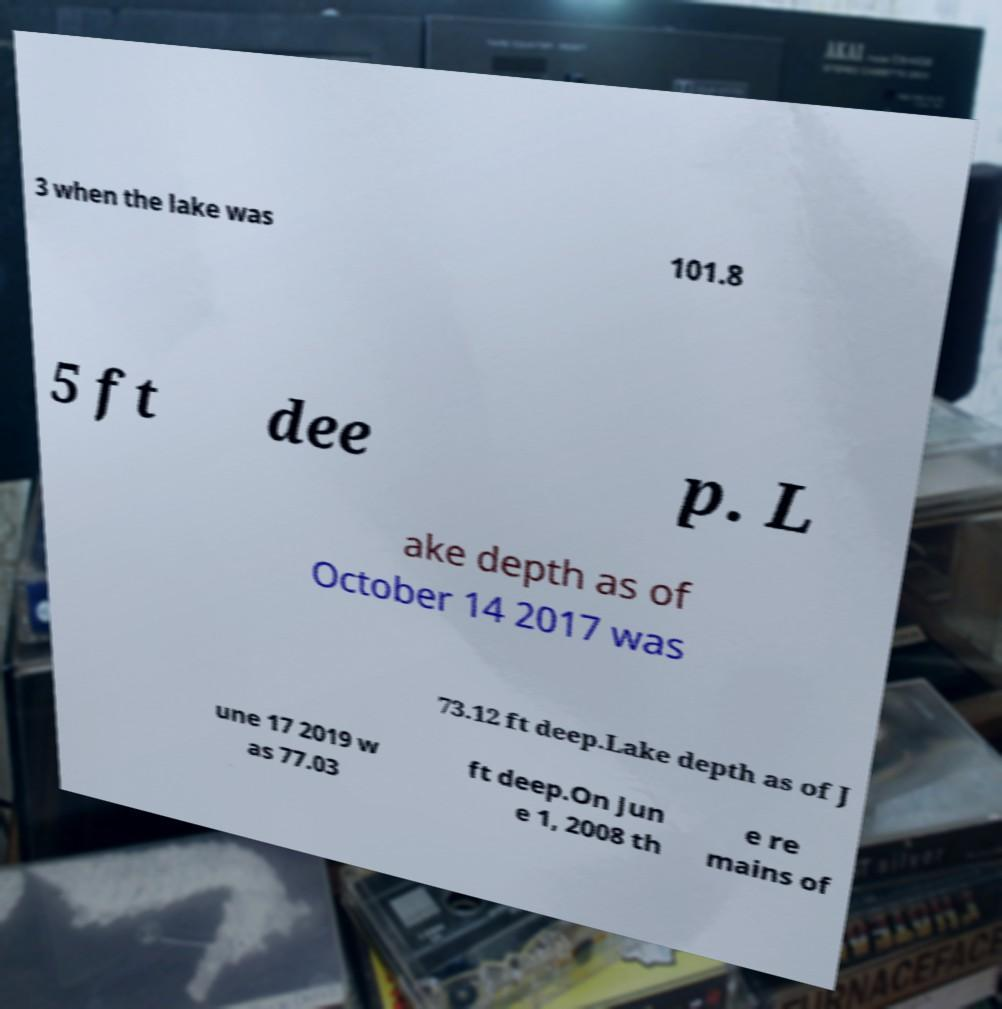For documentation purposes, I need the text within this image transcribed. Could you provide that? 3 when the lake was 101.8 5 ft dee p. L ake depth as of October 14 2017 was 73.12 ft deep.Lake depth as of J une 17 2019 w as 77.03 ft deep.On Jun e 1, 2008 th e re mains of 